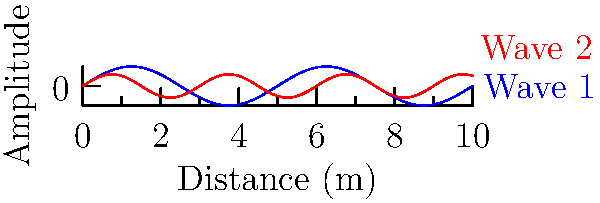In an underground tunnel, you want to create an immersive sound experience using two speakers. The speakers emit sound waves as shown in the graph, where the blue wave (Wave 1) has a wavelength of 5 m and the red wave (Wave 2) has a wavelength of 3 m. If the speed of sound in the tunnel is 340 m/s, what is the beat frequency that a listener would hear? To find the beat frequency, we need to follow these steps:

1. Calculate the frequency of each wave:
   For Wave 1: $f_1 = \frac{v}{\lambda_1} = \frac{340 \text{ m/s}}{5 \text{ m}} = 68 \text{ Hz}$
   For Wave 2: $f_2 = \frac{v}{\lambda_2} = \frac{340 \text{ m/s}}{3 \text{ m}} = 113.33 \text{ Hz}$

2. The beat frequency is the absolute difference between the two frequencies:
   $f_{beat} = |f_2 - f_1| = |113.33 \text{ Hz} - 68 \text{ Hz}| = 45.33 \text{ Hz}$

3. Round to the nearest whole number:
   $f_{beat} \approx 45 \text{ Hz}$

Therefore, a listener in the tunnel would hear a beat frequency of approximately 45 Hz, creating a pulsating effect in the immersive sound experience.
Answer: 45 Hz 